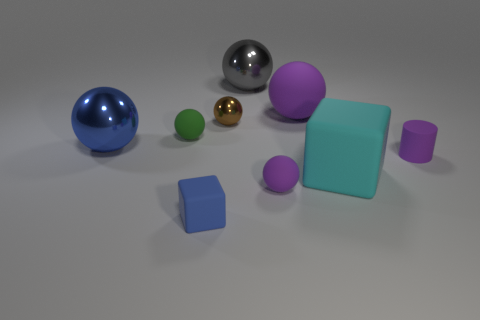What is the large blue ball made of?
Provide a succinct answer. Metal. How many other things are there of the same shape as the gray metal object?
Offer a very short reply. 5. The gray ball is what size?
Give a very brief answer. Large. How big is the thing that is to the left of the small metallic ball and in front of the large blue metal object?
Your answer should be compact. Small. The brown metal thing behind the green ball has what shape?
Ensure brevity in your answer.  Sphere. Is the cyan object made of the same material as the small sphere left of the brown shiny thing?
Offer a very short reply. Yes. Do the tiny blue rubber thing and the cyan rubber object have the same shape?
Your response must be concise. Yes. There is a large gray thing that is the same shape as the brown shiny thing; what is its material?
Your answer should be compact. Metal. What is the color of the matte object that is both on the right side of the blue matte object and behind the purple rubber cylinder?
Your response must be concise. Purple. The tiny shiny thing is what color?
Your response must be concise. Brown. 